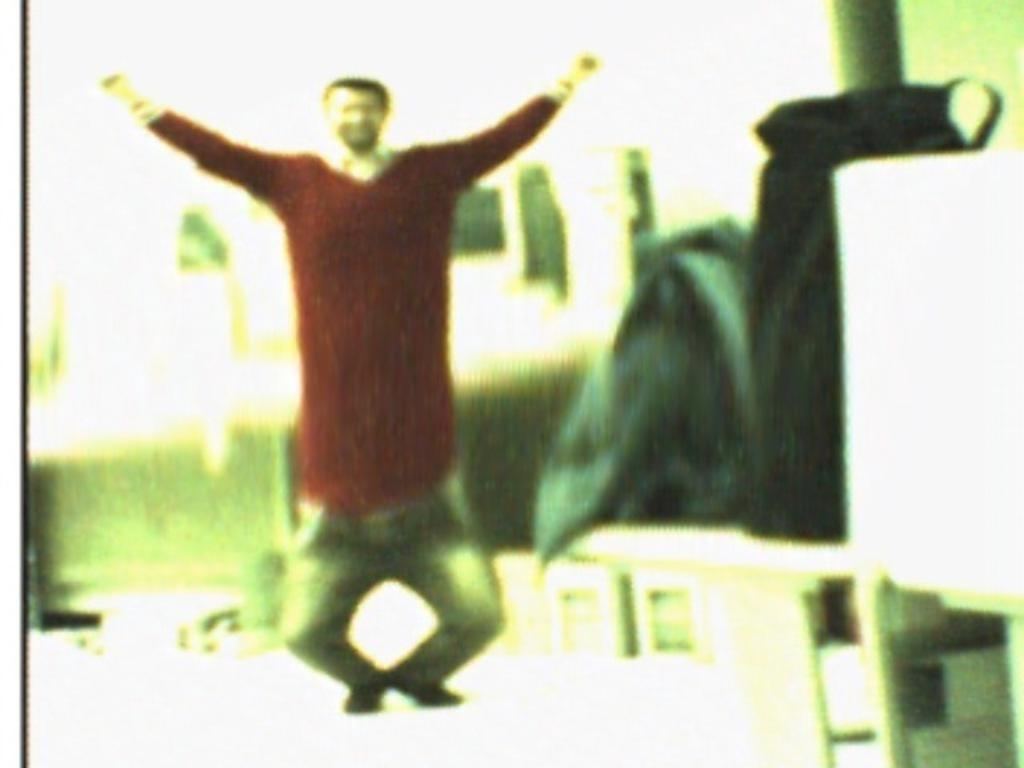What is the main subject in the foreground of the image? There is a man in the foreground of the image. What can be seen on the bench in the image? There are bags on a bench in the image. What type of soap is being used by the man in the image? There is no soap present in the image, and the man's actions are not described. 